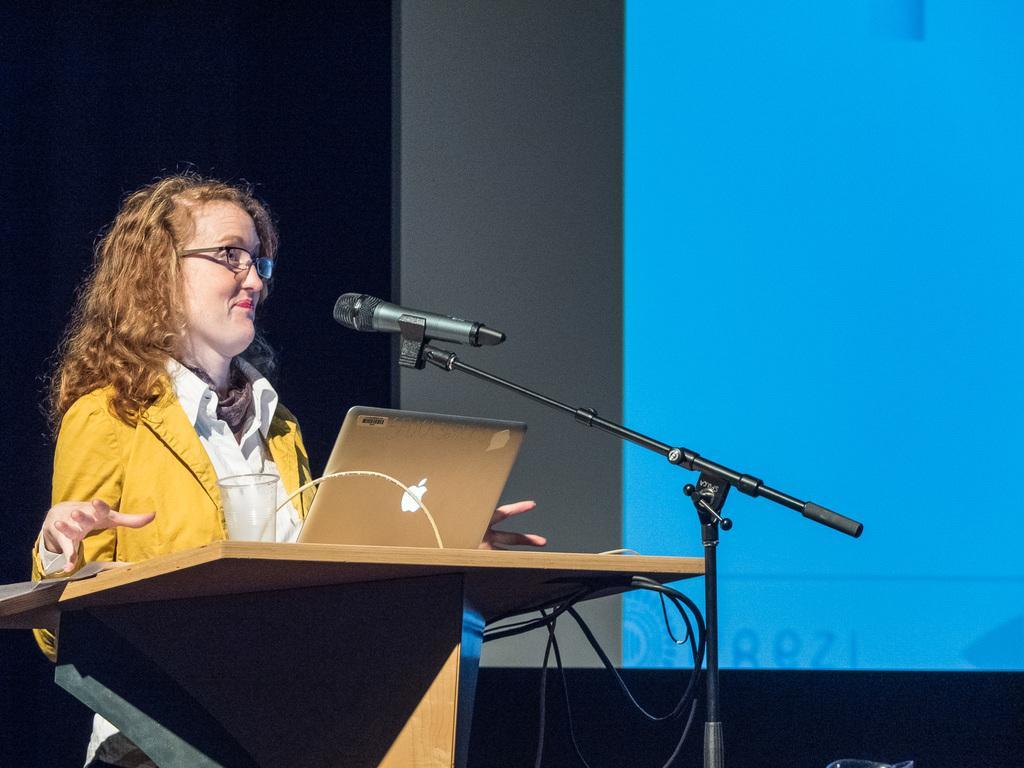Can you describe this image briefly? In this image there is one women standing at left side of this image is wearing white color shirt and orange color jacket and there is a table in front of her and there is a laptop in middle of this image and there is a mic in black color at middle right side of this image and there is a wall in the background. 